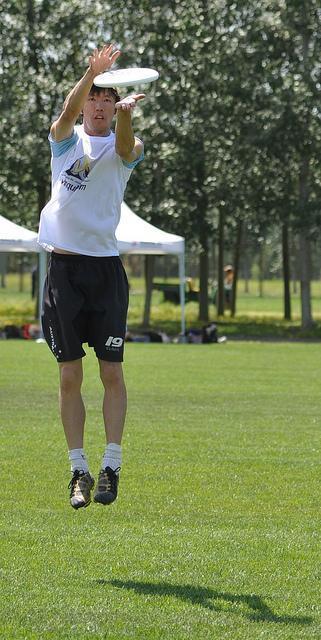How many of the train cars are yellow and red?
Give a very brief answer. 0. 